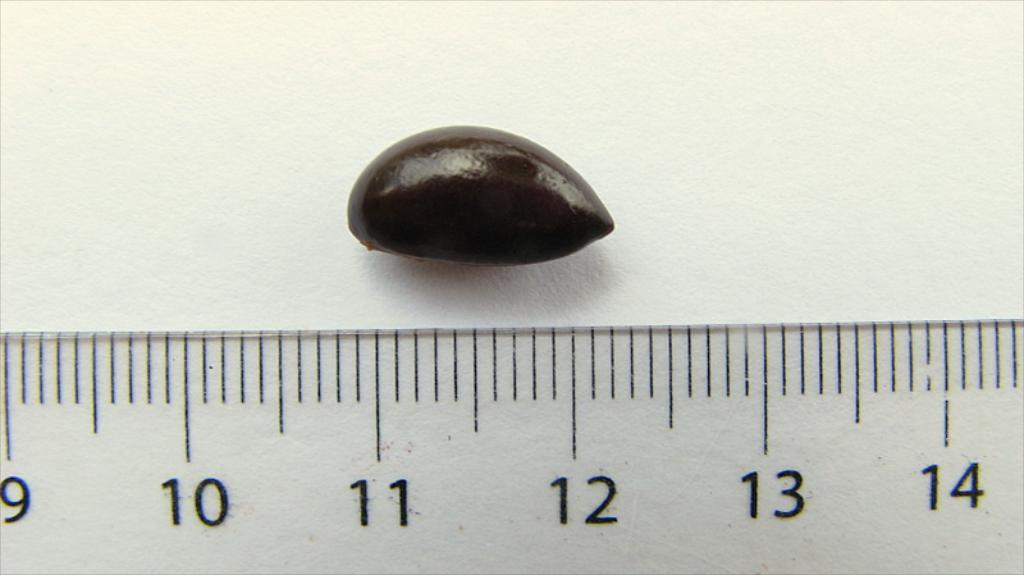<image>
Present a compact description of the photo's key features. Clear ruler with black number 11 measuring the size of a nut. 